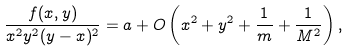Convert formula to latex. <formula><loc_0><loc_0><loc_500><loc_500>\frac { f ( x , y ) } { x ^ { 2 } y ^ { 2 } ( y - x ) ^ { 2 } } = a + O \left ( x ^ { 2 } + y ^ { 2 } + \frac { 1 } { m } + \frac { 1 } { M ^ { 2 } } \right ) ,</formula> 